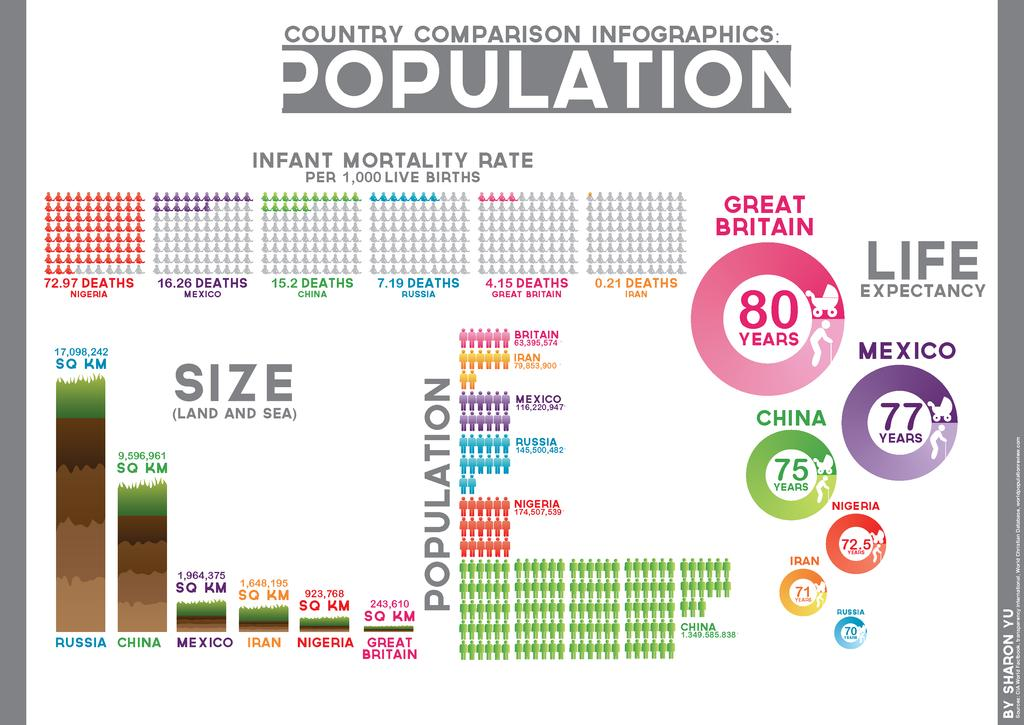Outline some significant characteristics in this image. Mexico has the second-highest life expectancy among countries. Great Britain has the second-lowest rate of infant mortality out of all countries. Iran has the second-lowest life expectancy among all countries. Russia has the third-highest population among all countries. The color that was previously used to represent Mexico is violet. 